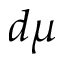<formula> <loc_0><loc_0><loc_500><loc_500>d \mu</formula> 